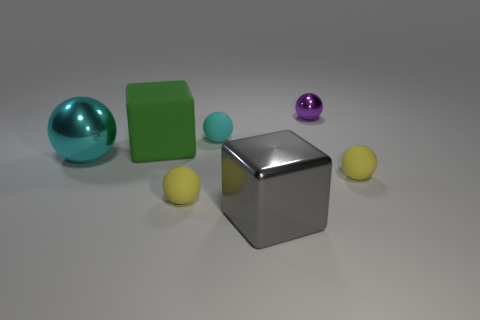Subtract all purple spheres. How many spheres are left? 4 Subtract all green spheres. Subtract all blue cylinders. How many spheres are left? 5 Add 3 tiny cyan matte objects. How many objects exist? 10 Subtract all blocks. How many objects are left? 5 Subtract all matte spheres. Subtract all big matte blocks. How many objects are left? 3 Add 5 purple objects. How many purple objects are left? 6 Add 4 large rubber things. How many large rubber things exist? 5 Subtract 0 yellow cylinders. How many objects are left? 7 